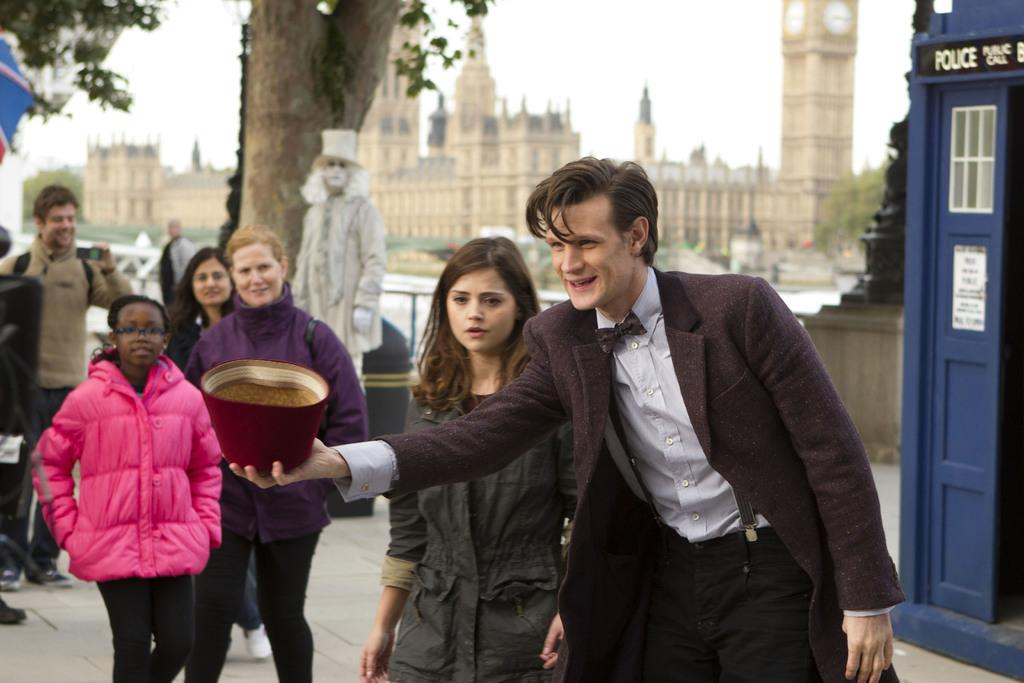What is the person in the image holding? The person is holding a cap in the image. How many people are present in the image? There are people in the image, but the exact number is not specified. What can be seen in the background of the image? There are buildings and trees in the background of the image. What type of shoes is the person wearing in the image? The provided facts do not mention any shoes, so we cannot determine the type of shoes the person is wearing. 